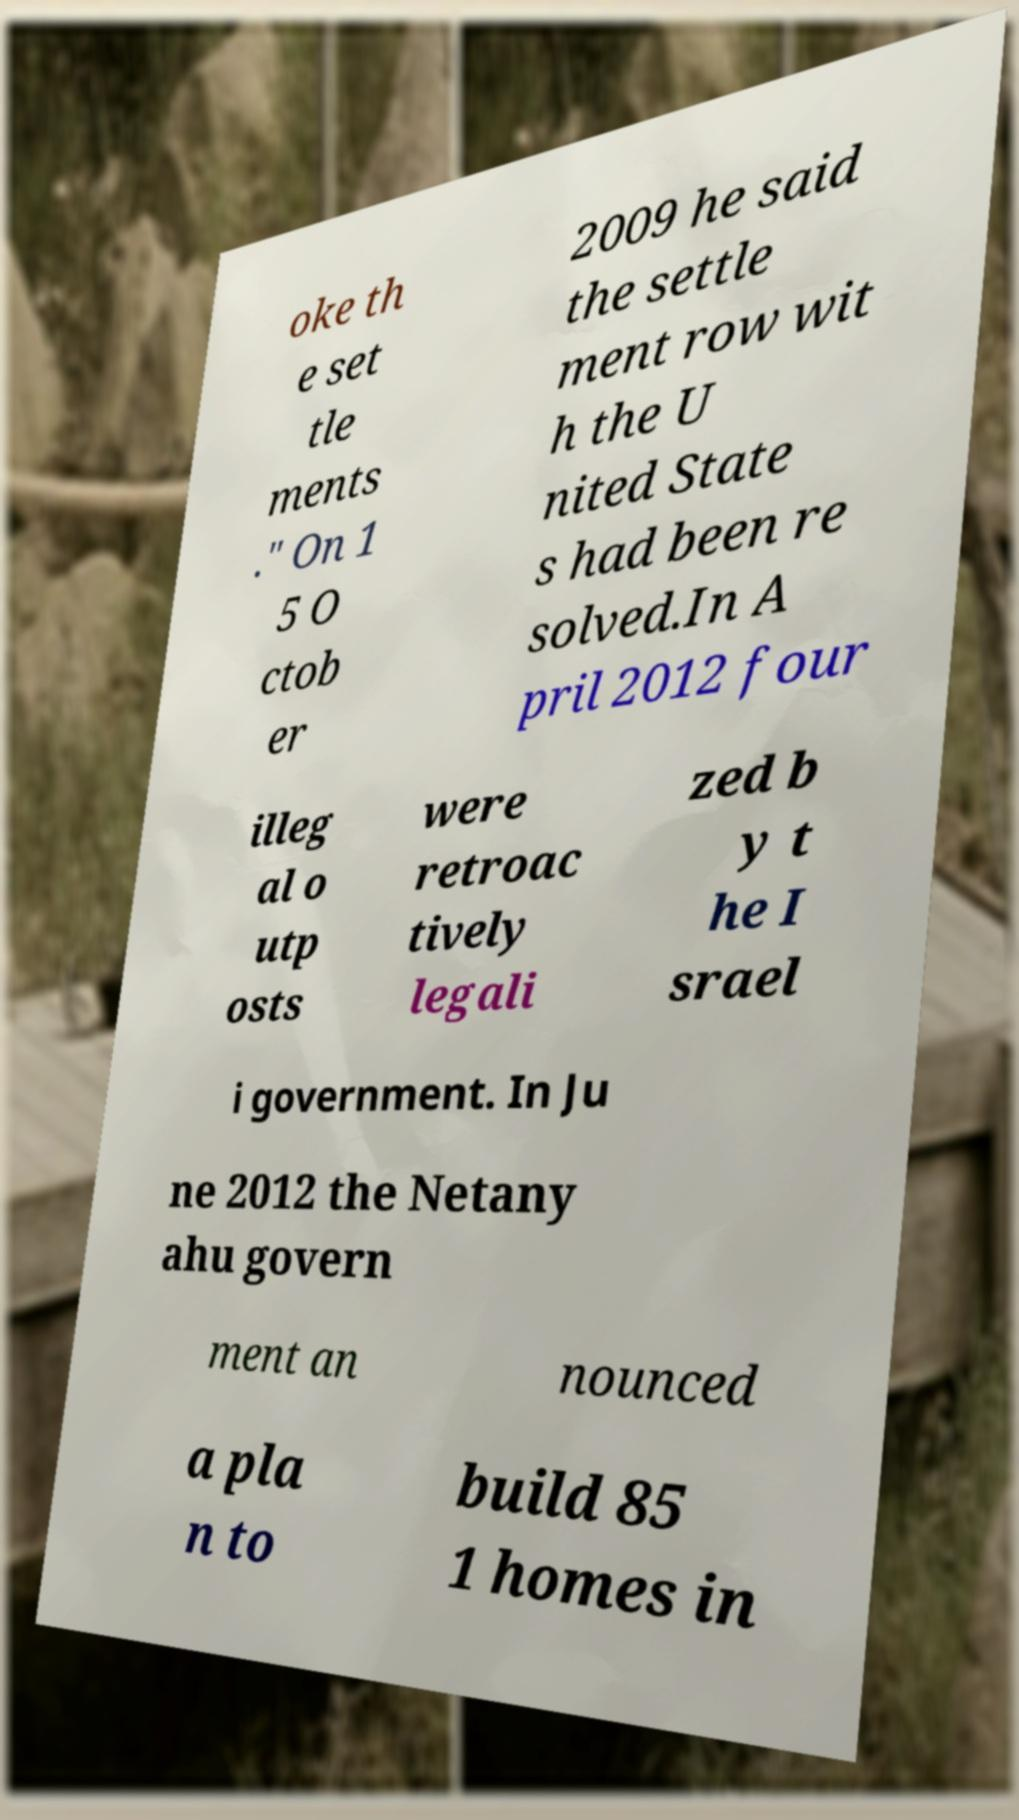Please identify and transcribe the text found in this image. oke th e set tle ments ." On 1 5 O ctob er 2009 he said the settle ment row wit h the U nited State s had been re solved.In A pril 2012 four illeg al o utp osts were retroac tively legali zed b y t he I srael i government. In Ju ne 2012 the Netany ahu govern ment an nounced a pla n to build 85 1 homes in 